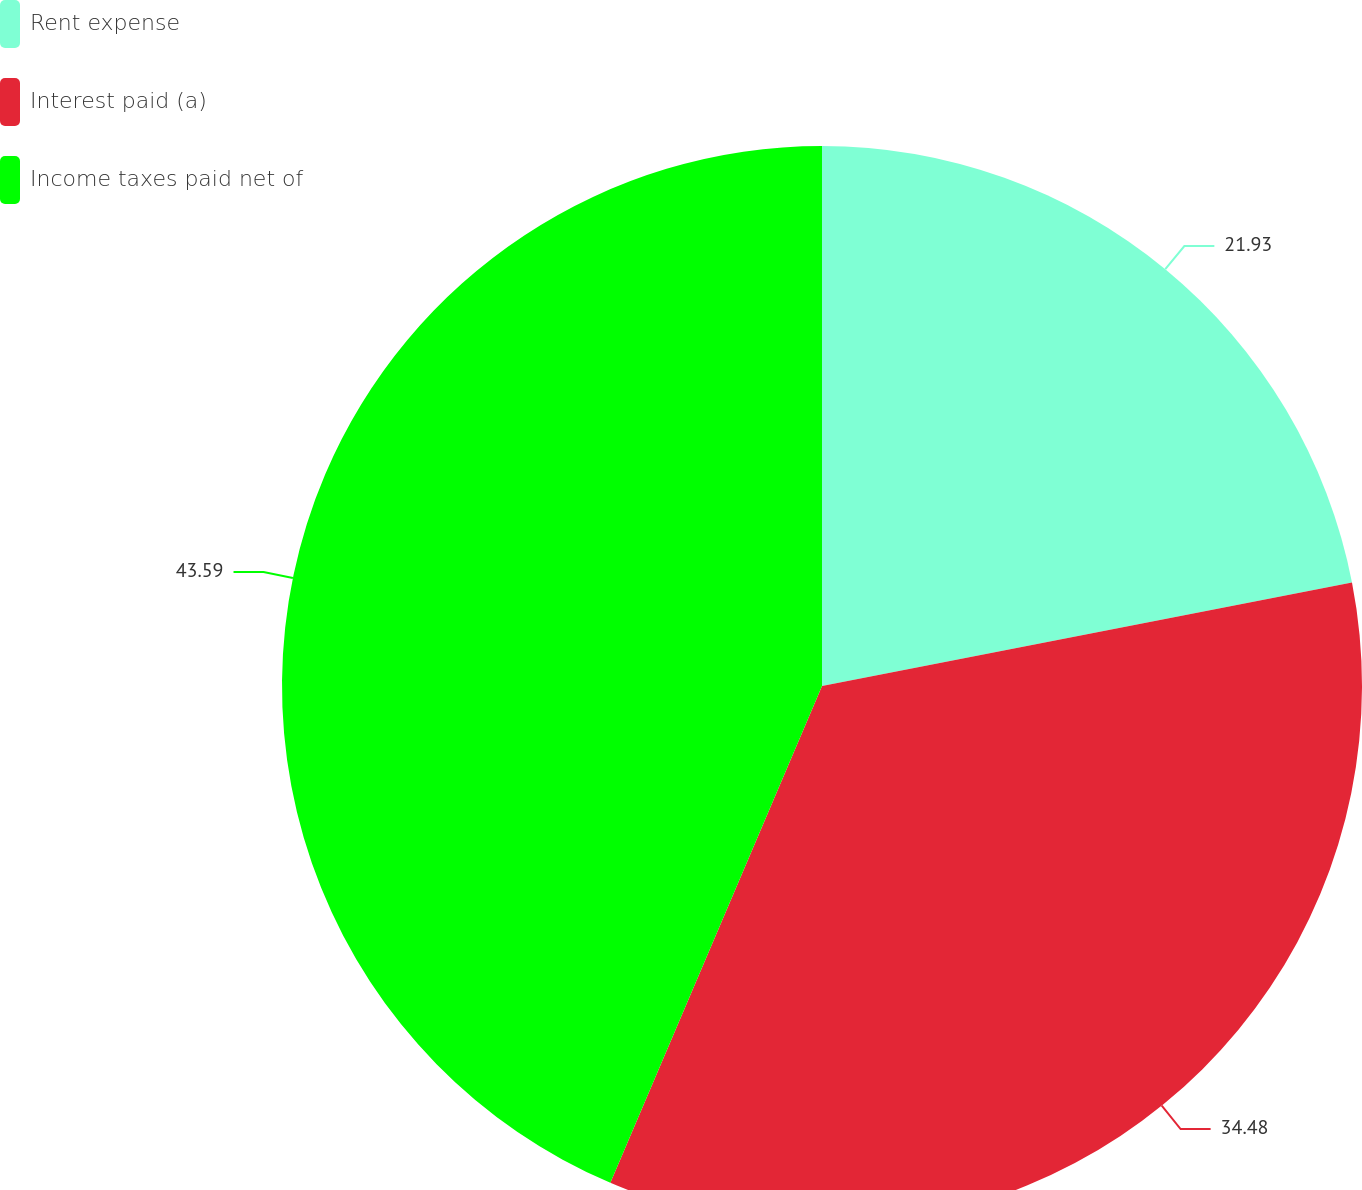Convert chart to OTSL. <chart><loc_0><loc_0><loc_500><loc_500><pie_chart><fcel>Rent expense<fcel>Interest paid (a)<fcel>Income taxes paid net of<nl><fcel>21.93%<fcel>34.48%<fcel>43.59%<nl></chart> 